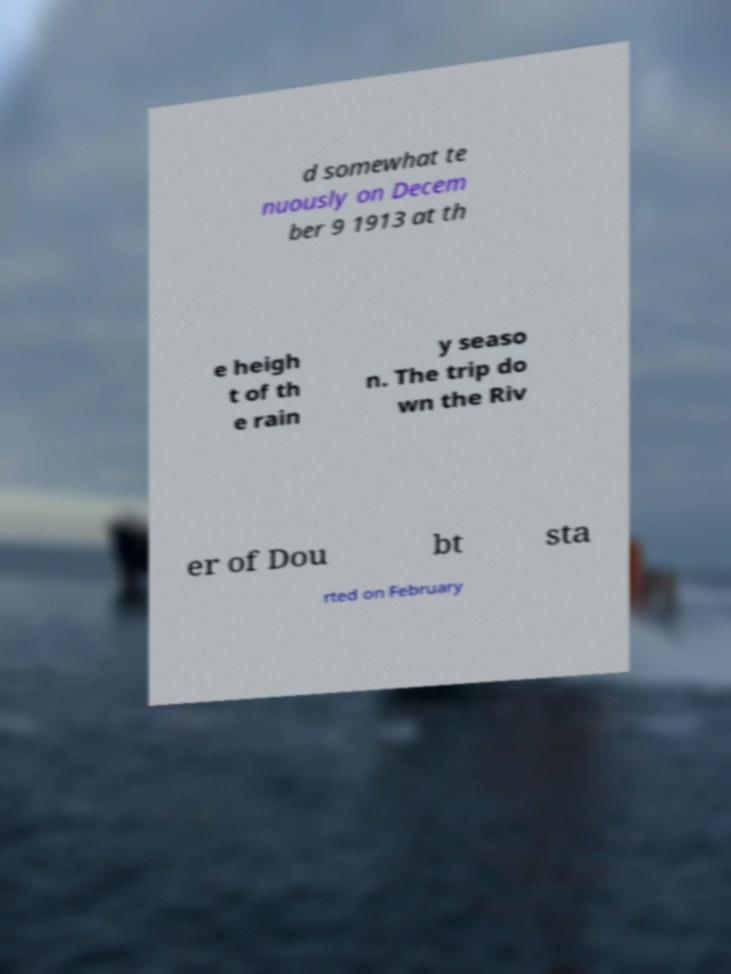Could you extract and type out the text from this image? d somewhat te nuously on Decem ber 9 1913 at th e heigh t of th e rain y seaso n. The trip do wn the Riv er of Dou bt sta rted on February 